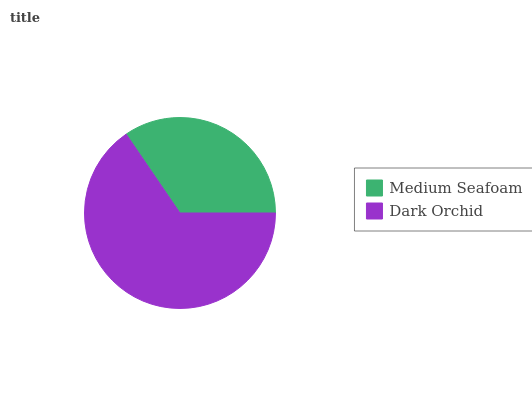Is Medium Seafoam the minimum?
Answer yes or no. Yes. Is Dark Orchid the maximum?
Answer yes or no. Yes. Is Dark Orchid the minimum?
Answer yes or no. No. Is Dark Orchid greater than Medium Seafoam?
Answer yes or no. Yes. Is Medium Seafoam less than Dark Orchid?
Answer yes or no. Yes. Is Medium Seafoam greater than Dark Orchid?
Answer yes or no. No. Is Dark Orchid less than Medium Seafoam?
Answer yes or no. No. Is Dark Orchid the high median?
Answer yes or no. Yes. Is Medium Seafoam the low median?
Answer yes or no. Yes. Is Medium Seafoam the high median?
Answer yes or no. No. Is Dark Orchid the low median?
Answer yes or no. No. 